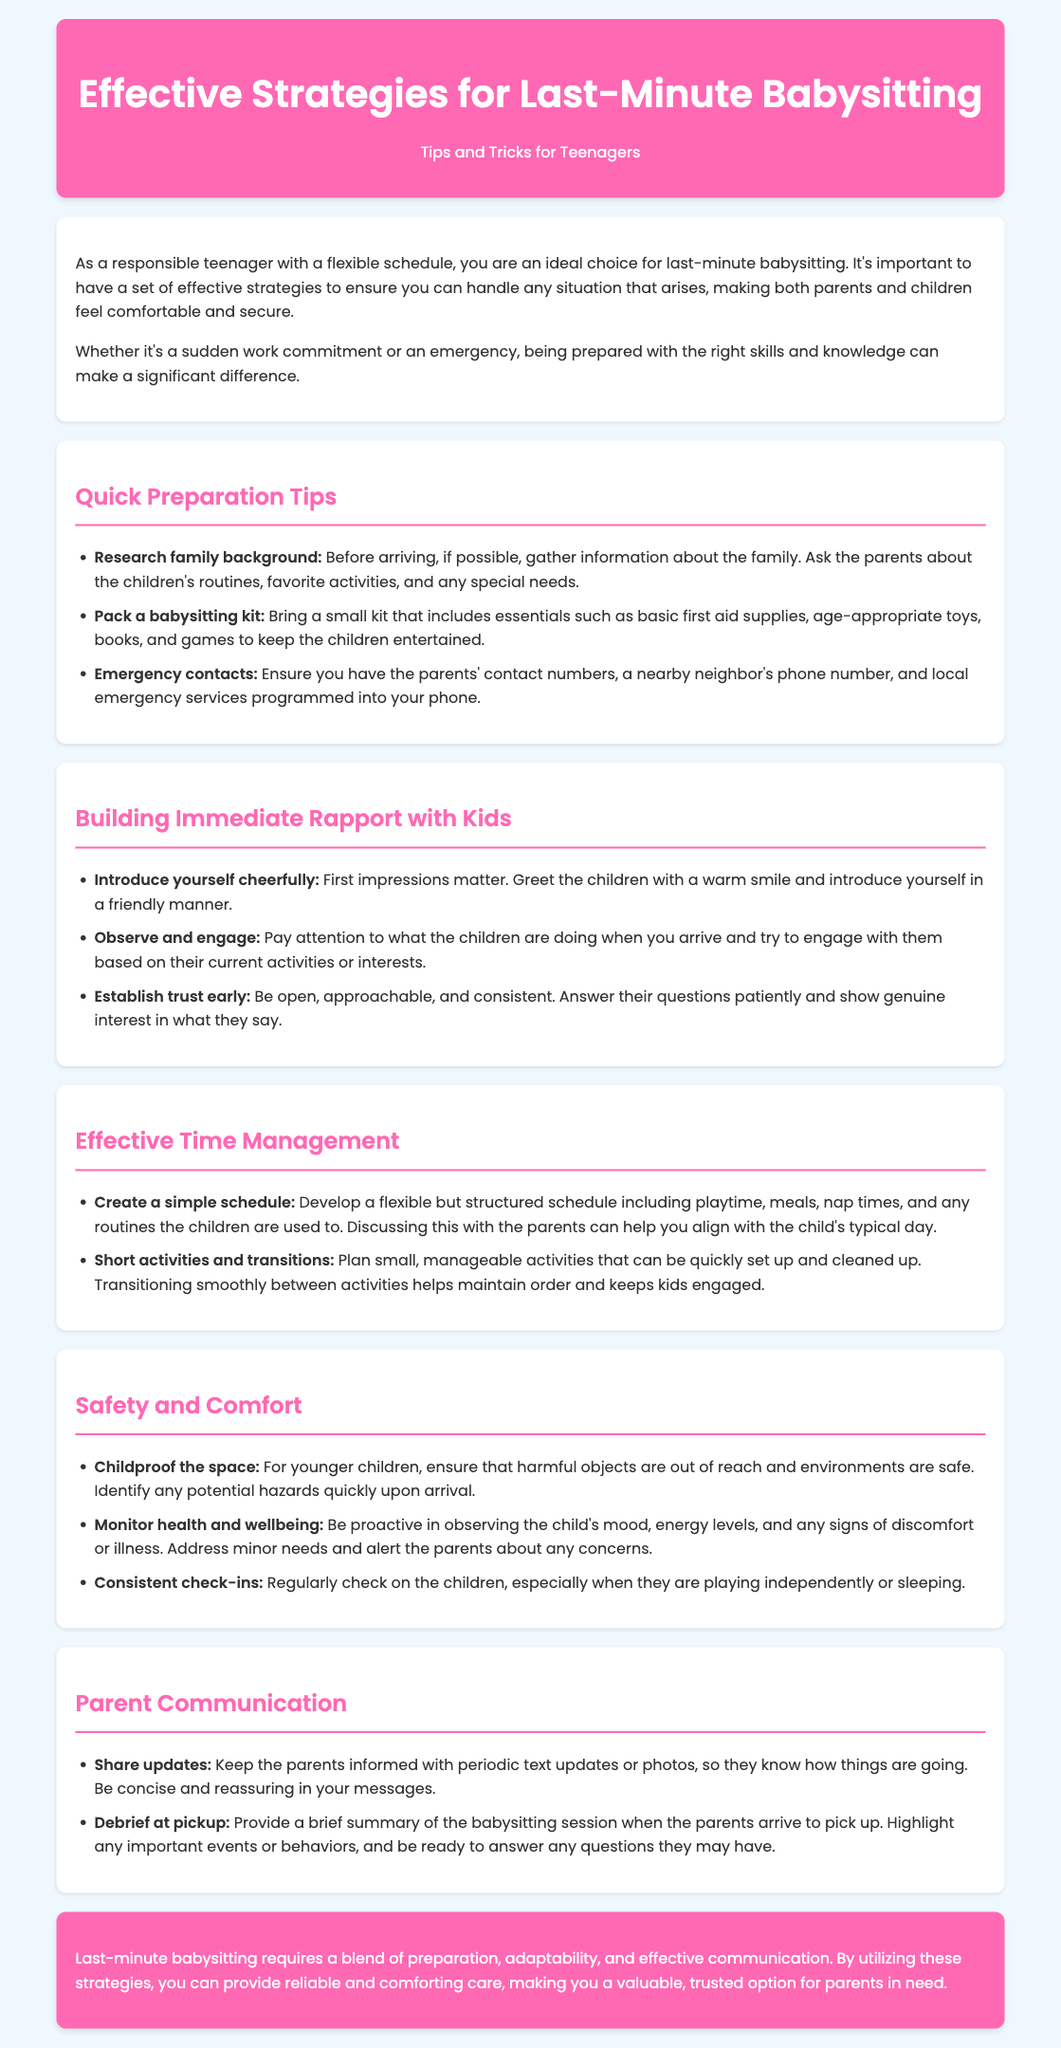What is the title of the whitepaper? The title is stated at the top of the document and is "Effective Strategies for Last-Minute Babysitting."
Answer: Effective Strategies for Last-Minute Babysitting What is one quick preparation tip mentioned in the document? The document outlines several quick preparation tips including "Research family background."
Answer: Research family background What is the color of the header background? The document states that the header background color is specified in the styling section.
Answer: Pink What should you include in a babysitting kit? The document suggests bringing essentials in a babysitting kit, such as "basic first aid supplies."
Answer: Basic first aid supplies What is a recommended way to build rapport with kids? One effective method described in the document is to "Introduce yourself cheerfully."
Answer: Introduce yourself cheerfully How many sections are listed under parent communication? The document contains several sections, and specifically mentions two distinct points under parent communication.
Answer: Two What is a key aspect of effective time management? The document highlights the importance of developing a "simple schedule."
Answer: Simple schedule How should you communicate with parents during babysitting? The document recommends that babysitters "Share updates."
Answer: Share updates 